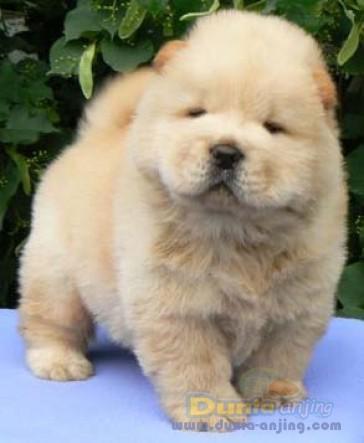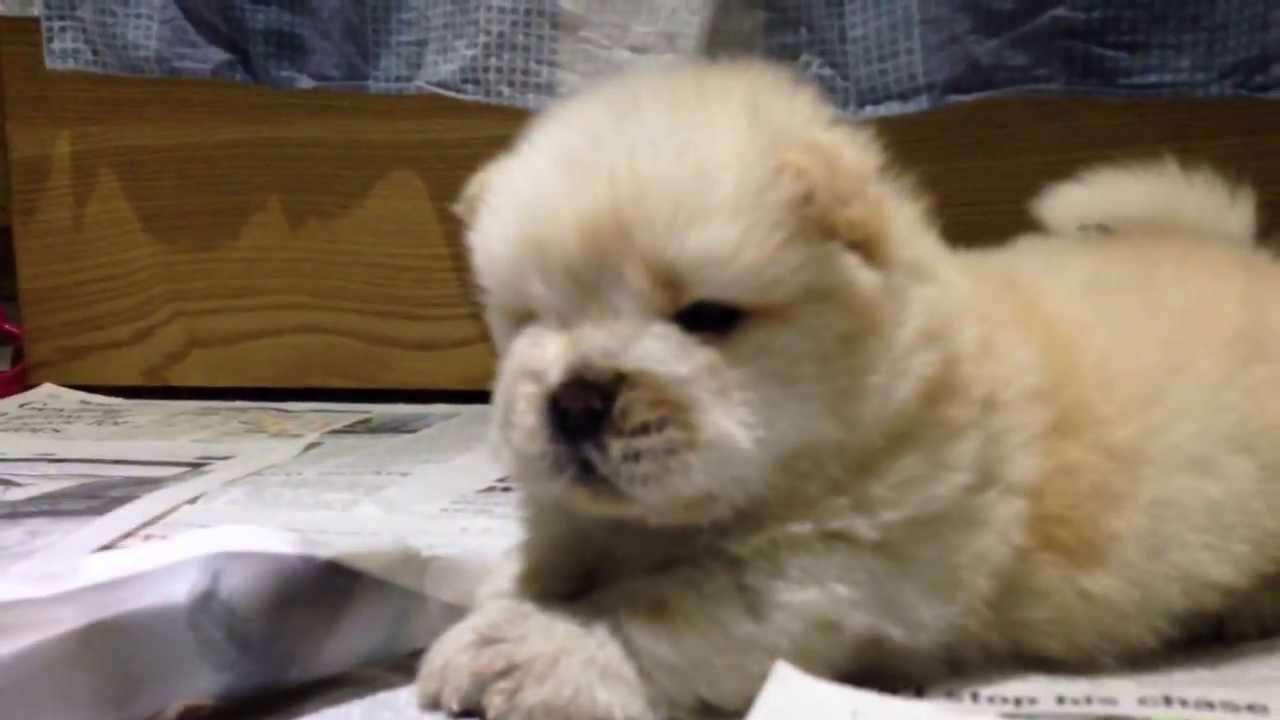The first image is the image on the left, the second image is the image on the right. For the images shown, is this caption "The dog in the image on the left is outside on a blue mat." true? Answer yes or no. Yes. The first image is the image on the left, the second image is the image on the right. Evaluate the accuracy of this statement regarding the images: "At least one image shows a cream-colored chow puppy posed on a solid blue, non-textured surface outdoors.". Is it true? Answer yes or no. Yes. 